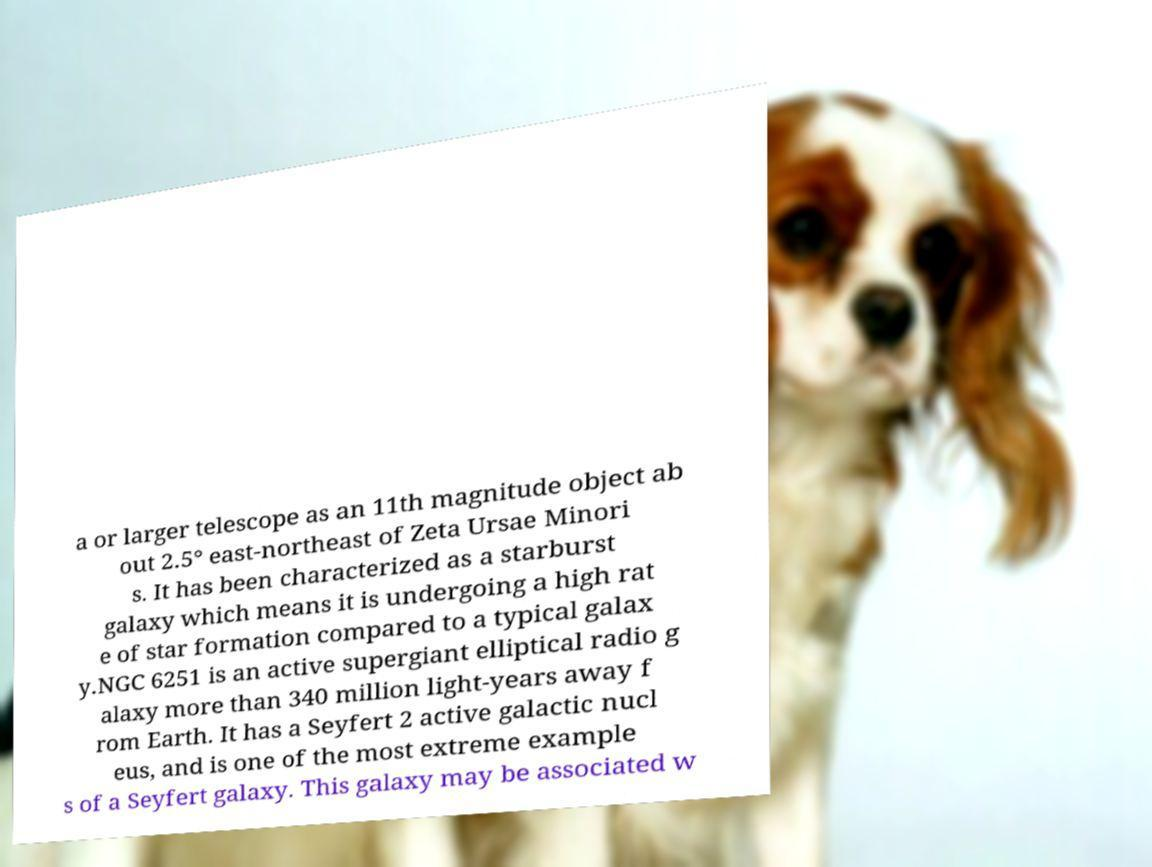Can you read and provide the text displayed in the image?This photo seems to have some interesting text. Can you extract and type it out for me? a or larger telescope as an 11th magnitude object ab out 2.5° east-northeast of Zeta Ursae Minori s. It has been characterized as a starburst galaxy which means it is undergoing a high rat e of star formation compared to a typical galax y.NGC 6251 is an active supergiant elliptical radio g alaxy more than 340 million light-years away f rom Earth. It has a Seyfert 2 active galactic nucl eus, and is one of the most extreme example s of a Seyfert galaxy. This galaxy may be associated w 